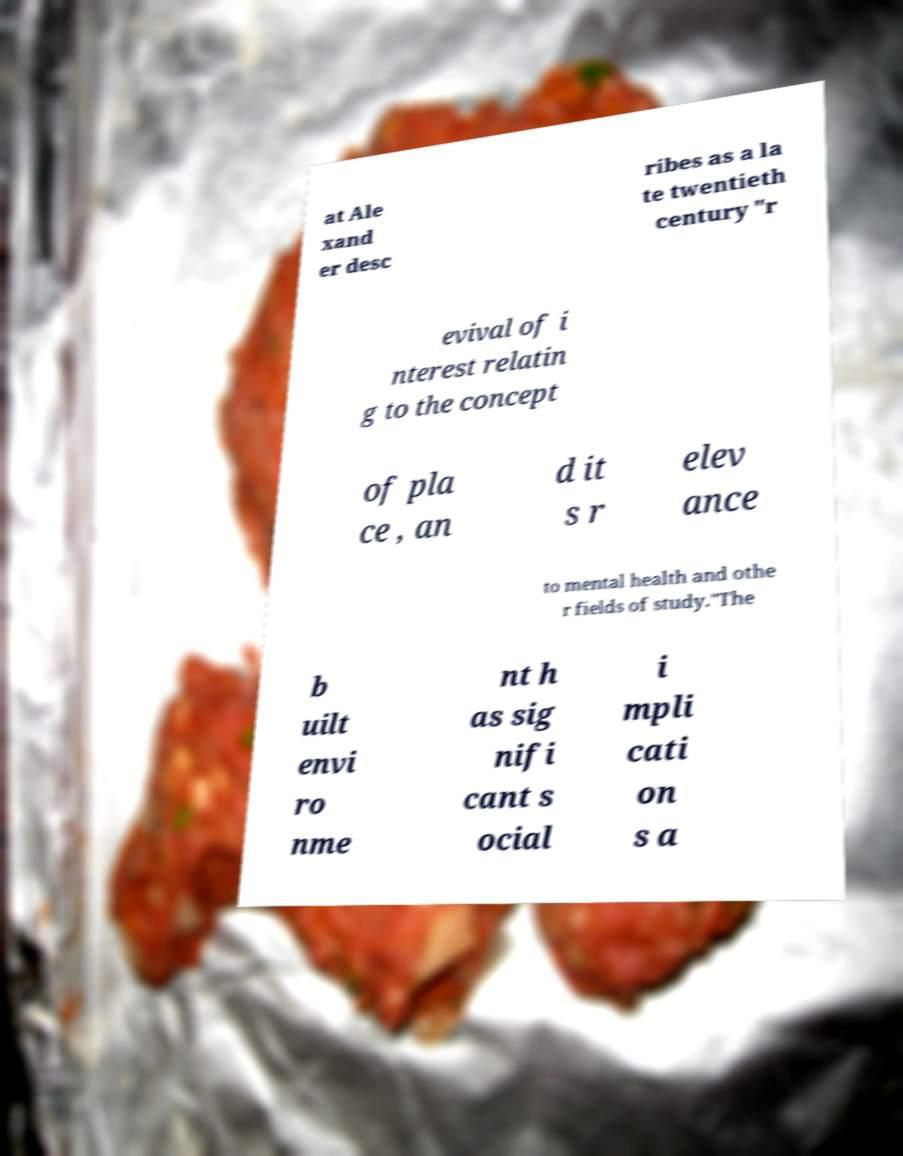Could you extract and type out the text from this image? at Ale xand er desc ribes as a la te twentieth century "r evival of i nterest relatin g to the concept of pla ce , an d it s r elev ance to mental health and othe r fields of study."The b uilt envi ro nme nt h as sig nifi cant s ocial i mpli cati on s a 